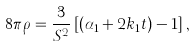Convert formula to latex. <formula><loc_0><loc_0><loc_500><loc_500>8 \pi \rho = \frac { 3 } { S ^ { 2 } } \left [ ( \alpha _ { 1 } + 2 k _ { 1 } t ) - 1 \right ] ,</formula> 